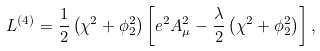<formula> <loc_0><loc_0><loc_500><loc_500>L ^ { ( 4 ) } = \frac { 1 } { 2 } \left ( \chi ^ { 2 } + \phi _ { 2 } ^ { 2 } \right ) \left [ e ^ { 2 } A _ { \mu } ^ { 2 } - \frac { \lambda } { 2 } \left ( \chi ^ { 2 } + \phi _ { 2 } ^ { 2 } \right ) \right ] ,</formula> 